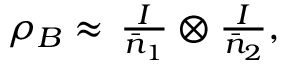Convert formula to latex. <formula><loc_0><loc_0><loc_500><loc_500>\begin{array} { r } { \rho _ { B } \approx \, \frac { I } { \bar { n } _ { 1 } } \otimes \frac { I } { \bar { n } _ { 2 } } , } \end{array}</formula> 